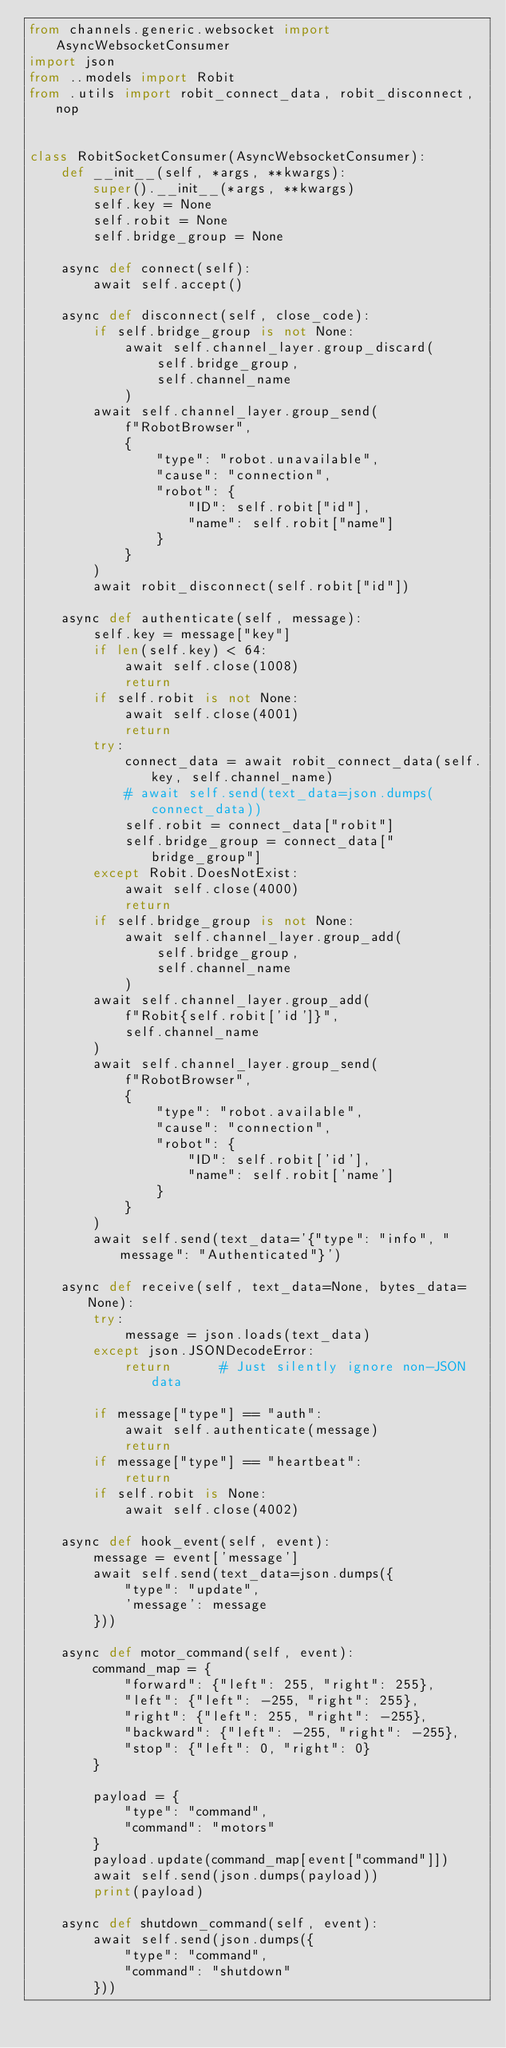<code> <loc_0><loc_0><loc_500><loc_500><_Python_>from channels.generic.websocket import AsyncWebsocketConsumer
import json
from ..models import Robit
from .utils import robit_connect_data, robit_disconnect, nop


class RobitSocketConsumer(AsyncWebsocketConsumer):
    def __init__(self, *args, **kwargs):
        super().__init__(*args, **kwargs)
        self.key = None
        self.robit = None
        self.bridge_group = None

    async def connect(self):
        await self.accept()

    async def disconnect(self, close_code):
        if self.bridge_group is not None:
            await self.channel_layer.group_discard(
                self.bridge_group,
                self.channel_name
            )
        await self.channel_layer.group_send(
            f"RobotBrowser",
            {
                "type": "robot.unavailable",
                "cause": "connection",
                "robot": {
                    "ID": self.robit["id"],
                    "name": self.robit["name"]
                }
            }
        )
        await robit_disconnect(self.robit["id"])

    async def authenticate(self, message):
        self.key = message["key"]
        if len(self.key) < 64:
            await self.close(1008)
            return
        if self.robit is not None:
            await self.close(4001)
            return
        try:
            connect_data = await robit_connect_data(self.key, self.channel_name)
            # await self.send(text_data=json.dumps(connect_data))
            self.robit = connect_data["robit"]
            self.bridge_group = connect_data["bridge_group"]
        except Robit.DoesNotExist:
            await self.close(4000)
            return
        if self.bridge_group is not None:
            await self.channel_layer.group_add(
                self.bridge_group,
                self.channel_name
            )
        await self.channel_layer.group_add(
            f"Robit{self.robit['id']}",
            self.channel_name
        )
        await self.channel_layer.group_send(
            f"RobotBrowser",
            {
                "type": "robot.available",
                "cause": "connection",
                "robot": {
                    "ID": self.robit['id'],
                    "name": self.robit['name']
                }
            }
        )
        await self.send(text_data='{"type": "info", "message": "Authenticated"}')

    async def receive(self, text_data=None, bytes_data=None):
        try:
            message = json.loads(text_data)
        except json.JSONDecodeError:
            return      # Just silently ignore non-JSON data

        if message["type"] == "auth":
            await self.authenticate(message)
            return
        if message["type"] == "heartbeat":
            return
        if self.robit is None:
            await self.close(4002)

    async def hook_event(self, event):
        message = event['message']
        await self.send(text_data=json.dumps({
            "type": "update",
            'message': message
        }))

    async def motor_command(self, event):
        command_map = {
            "forward": {"left": 255, "right": 255},
            "left": {"left": -255, "right": 255},
            "right": {"left": 255, "right": -255},
            "backward": {"left": -255, "right": -255},
            "stop": {"left": 0, "right": 0}
        }

        payload = {
            "type": "command",
            "command": "motors"
        }
        payload.update(command_map[event["command"]])
        await self.send(json.dumps(payload))
        print(payload)

    async def shutdown_command(self, event):
        await self.send(json.dumps({
            "type": "command",
            "command": "shutdown"
        }))
</code> 